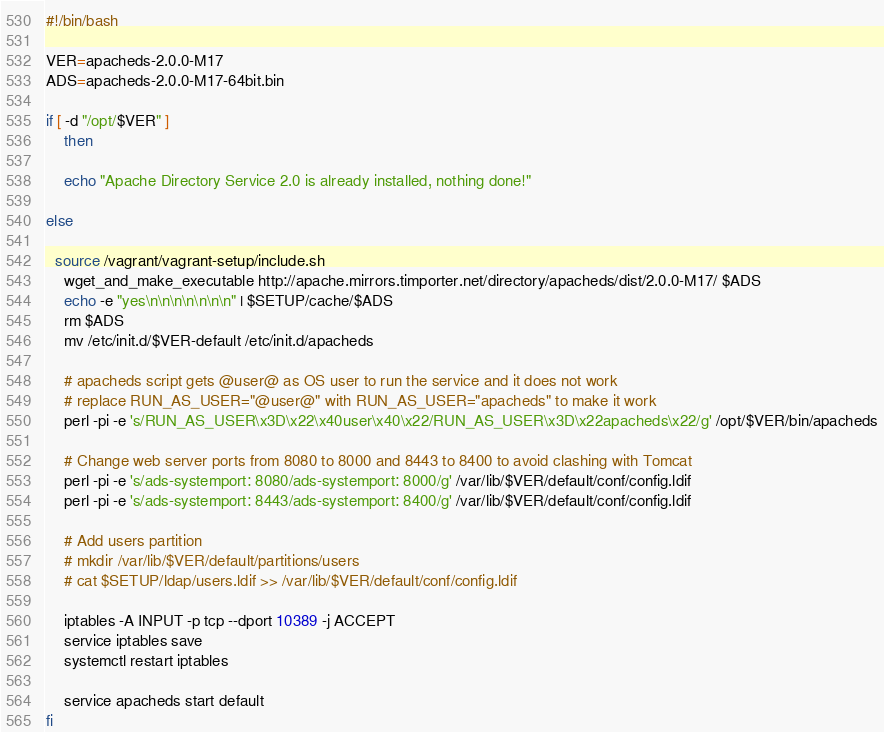<code> <loc_0><loc_0><loc_500><loc_500><_Bash_>#!/bin/bash

VER=apacheds-2.0.0-M17
ADS=apacheds-2.0.0-M17-64bit.bin

if [ -d "/opt/$VER" ]
	then

	echo "Apache Directory Service 2.0 is already installed, nothing done!"

else

  source /vagrant/vagrant-setup/include.sh
	wget_and_make_executable http://apache.mirrors.timporter.net/directory/apacheds/dist/2.0.0-M17/ $ADS
	echo -e "yes\n\n\n\n\n\n\n" | $SETUP/cache/$ADS
	rm $ADS
	mv /etc/init.d/$VER-default /etc/init.d/apacheds
	
	# apacheds script gets @user@ as OS user to run the service and it does not work
	# replace RUN_AS_USER="@user@" with RUN_AS_USER="apacheds" to make it work
	perl -pi -e 's/RUN_AS_USER\x3D\x22\x40user\x40\x22/RUN_AS_USER\x3D\x22apacheds\x22/g' /opt/$VER/bin/apacheds

	# Change web server ports from 8080 to 8000 and 8443 to 8400 to avoid clashing with Tomcat
	perl -pi -e 's/ads-systemport: 8080/ads-systemport: 8000/g' /var/lib/$VER/default/conf/config.ldif
	perl -pi -e 's/ads-systemport: 8443/ads-systemport: 8400/g' /var/lib/$VER/default/conf/config.ldif

	# Add users partition
	# mkdir /var/lib/$VER/default/partitions/users
	# cat $SETUP/ldap/users.ldif >> /var/lib/$VER/default/conf/config.ldif

	iptables -A INPUT -p tcp --dport 10389 -j ACCEPT
	service iptables save
	systemctl restart iptables

	service apacheds start default
fi</code> 